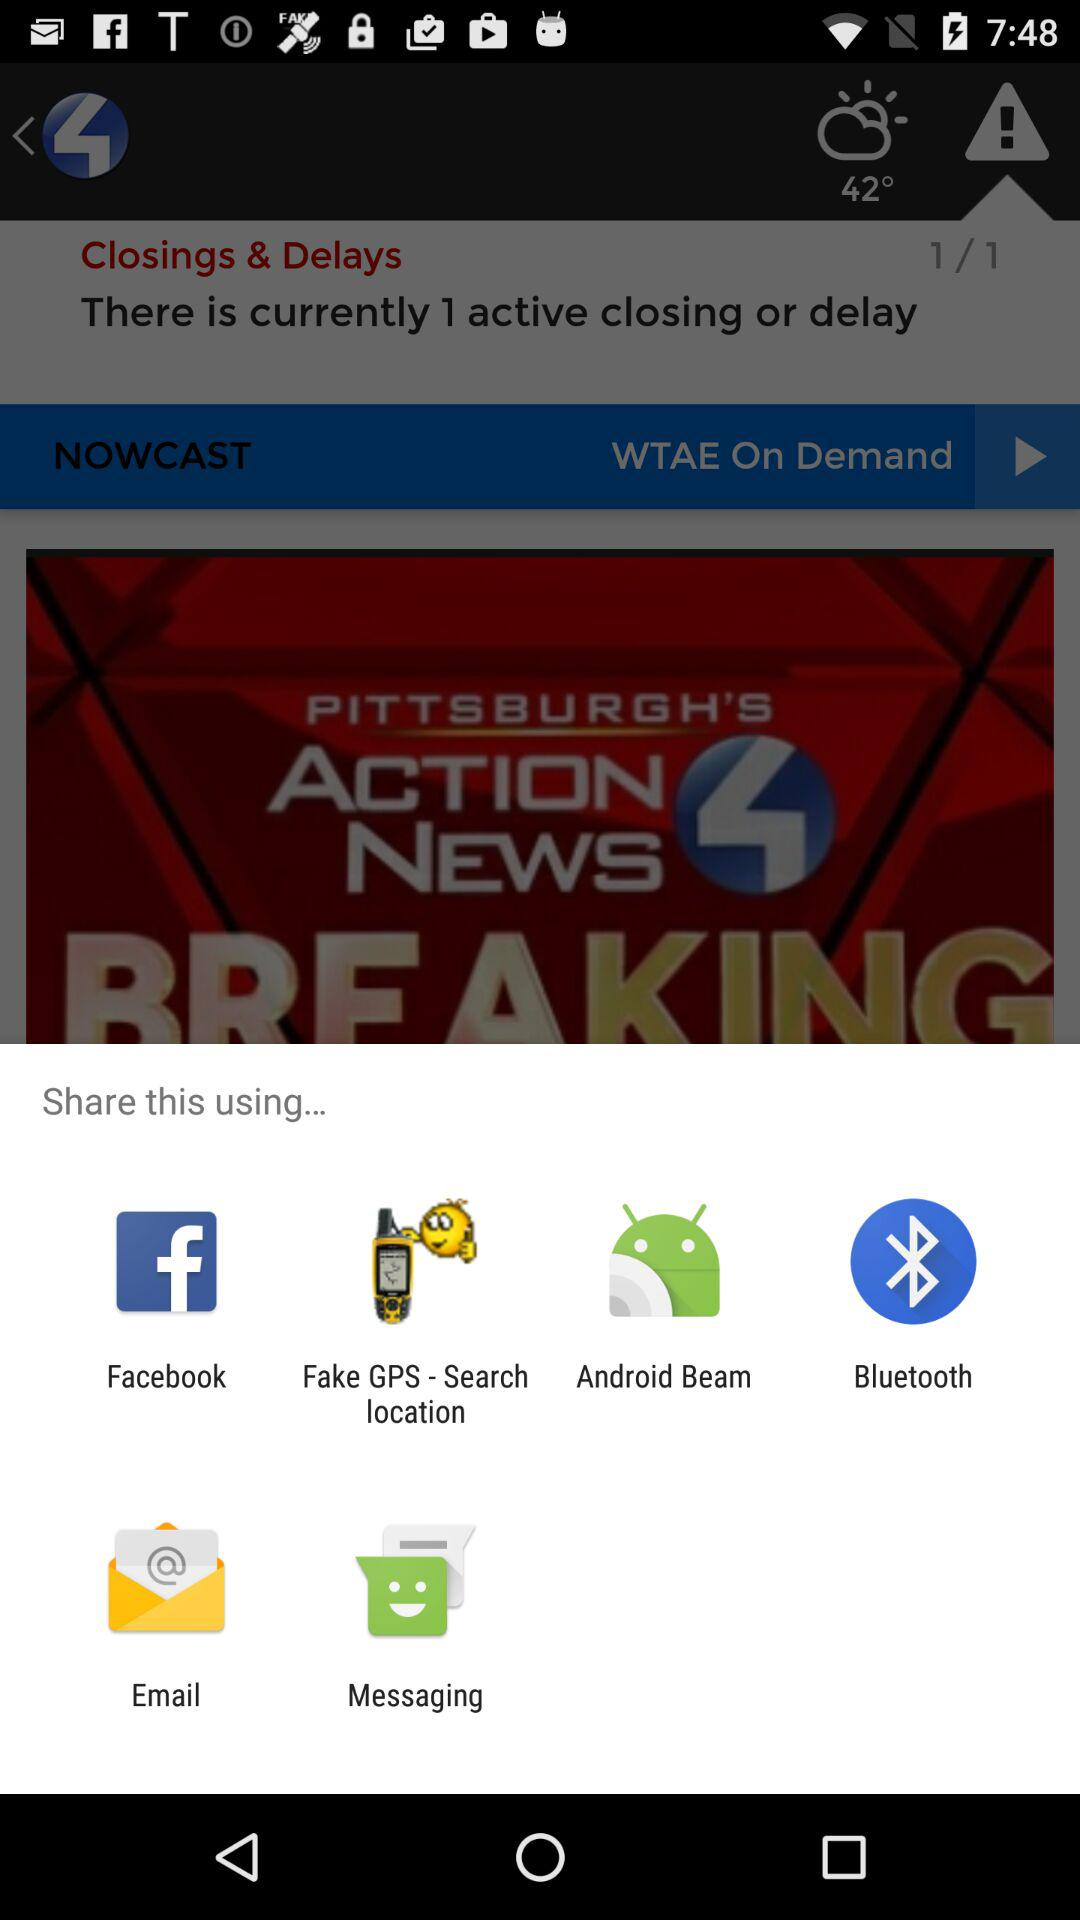What application can I use to share? The applications are "Facebook", "Fake GPS - Search location", "Android Beam", "Bluetooth", "Email" and "Messaging". 